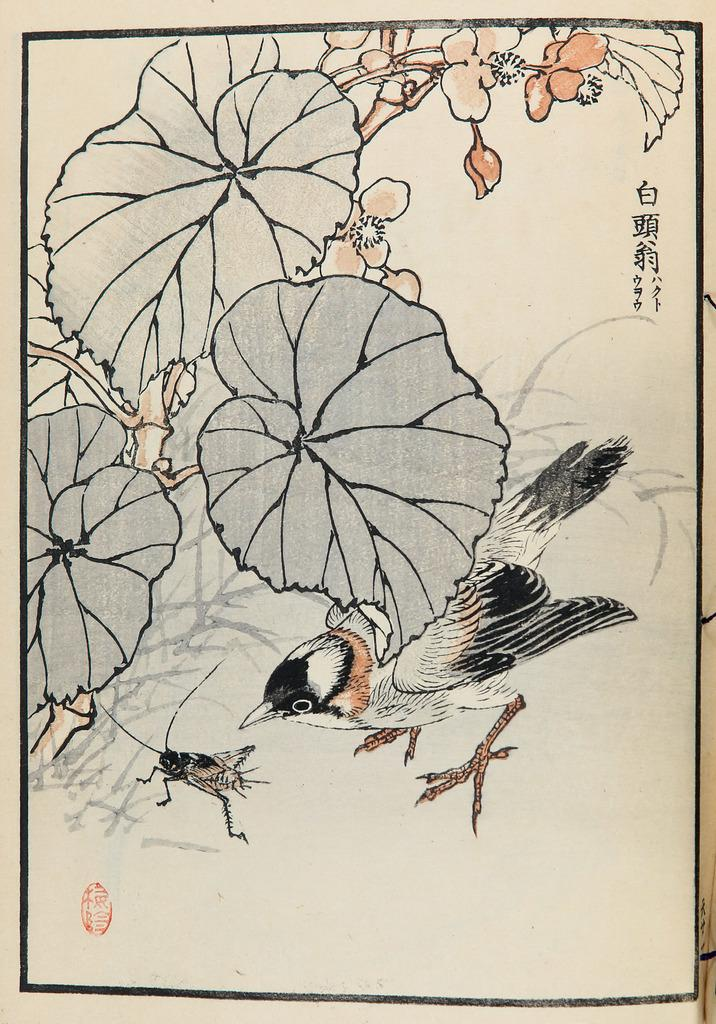What is the main subject of the painting in the image? The painting depicts a bird. What other elements are present in the painting? The painting also depicts an insect, leaves, and flowers. What time of day does the painting depict? The painting does not depict a specific time of day, so it cannot be determined from the image. 